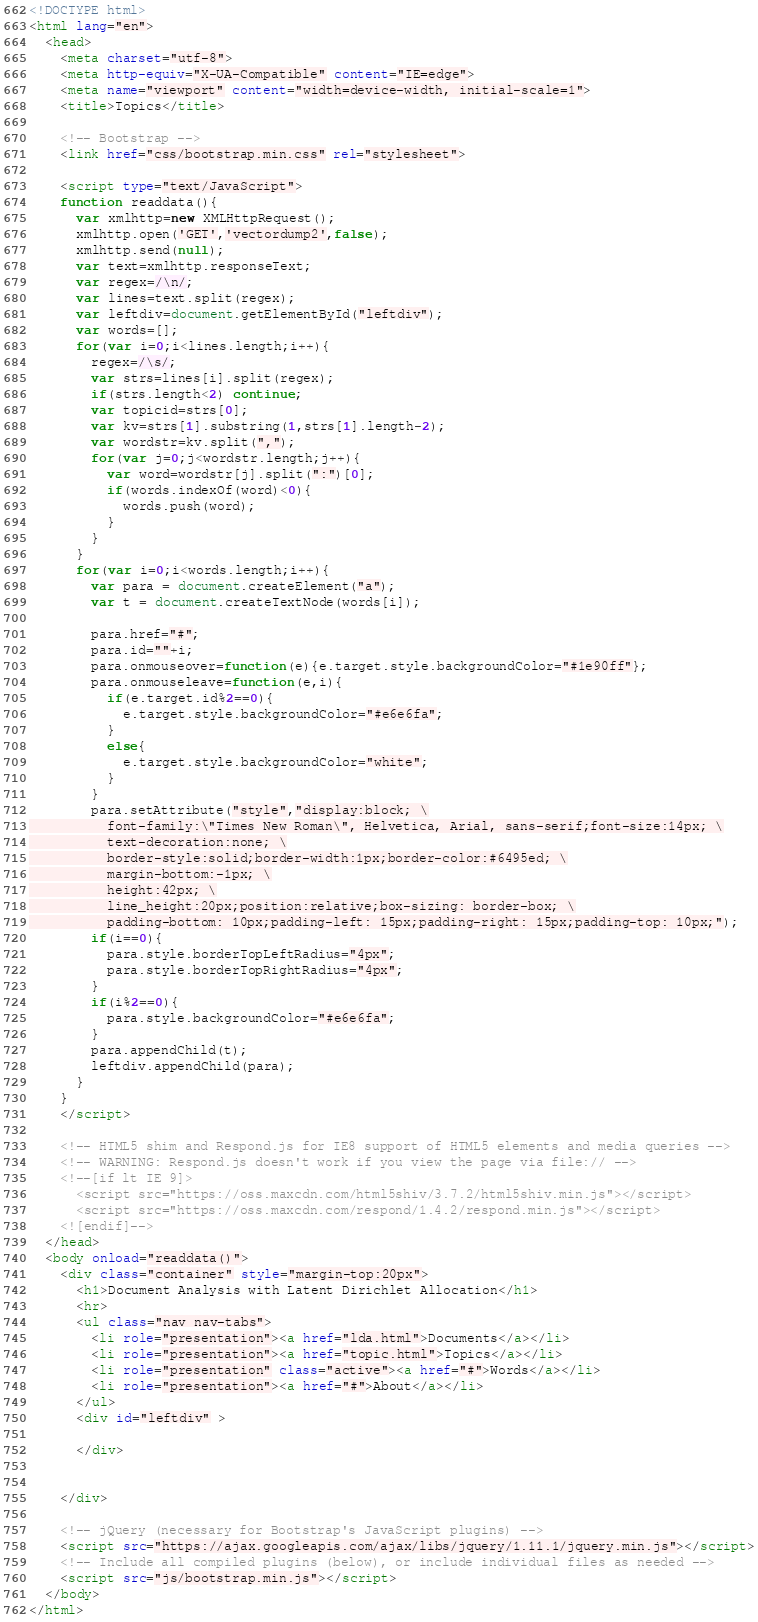Convert code to text. <code><loc_0><loc_0><loc_500><loc_500><_HTML_><!DOCTYPE html>
<html lang="en">
  <head>
    <meta charset="utf-8">
    <meta http-equiv="X-UA-Compatible" content="IE=edge">
    <meta name="viewport" content="width=device-width, initial-scale=1">
    <title>Topics</title>

    <!-- Bootstrap -->
    <link href="css/bootstrap.min.css" rel="stylesheet">

    <script type="text/JavaScript">
    function readdata(){
      var xmlhttp=new XMLHttpRequest();
      xmlhttp.open('GET','vectordump2',false);
      xmlhttp.send(null);
      var text=xmlhttp.responseText;
      var regex=/\n/;
      var lines=text.split(regex);
      var leftdiv=document.getElementById("leftdiv");
      var words=[];
      for(var i=0;i<lines.length;i++){
        regex=/\s/;
        var strs=lines[i].split(regex);
        if(strs.length<2) continue;
        var topicid=strs[0];
        var kv=strs[1].substring(1,strs[1].length-2);
        var wordstr=kv.split(",");
        for(var j=0;j<wordstr.length;j++){
          var word=wordstr[j].split(":")[0];
          if(words.indexOf(word)<0){
            words.push(word);
          }
        }
      }
      for(var i=0;i<words.length;i++){
        var para = document.createElement("a");
        var t = document.createTextNode(words[i]);

        para.href="#";
        para.id=""+i;
        para.onmouseover=function(e){e.target.style.backgroundColor="#1e90ff"};
        para.onmouseleave=function(e,i){
          if(e.target.id%2==0){
            e.target.style.backgroundColor="#e6e6fa";
          }
          else{
            e.target.style.backgroundColor="white";
          }
        }
        para.setAttribute("style","display:block; \
          font-family:\"Times New Roman\", Helvetica, Arial, sans-serif;font-size:14px; \
          text-decoration:none; \
          border-style:solid;border-width:1px;border-color:#6495ed; \
          margin-bottom:-1px; \
          height:42px; \
          line_height:20px;position:relative;box-sizing: border-box; \
          padding-bottom: 10px;padding-left: 15px;padding-right: 15px;padding-top: 10px;");
        if(i==0){
          para.style.borderTopLeftRadius="4px";
          para.style.borderTopRightRadius="4px";
        }
        if(i%2==0){
          para.style.backgroundColor="#e6e6fa";
        }
        para.appendChild(t);
        leftdiv.appendChild(para); 
      }
    }
    </script>

    <!-- HTML5 shim and Respond.js for IE8 support of HTML5 elements and media queries -->
    <!-- WARNING: Respond.js doesn't work if you view the page via file:// -->
    <!--[if lt IE 9]>
      <script src="https://oss.maxcdn.com/html5shiv/3.7.2/html5shiv.min.js"></script>
      <script src="https://oss.maxcdn.com/respond/1.4.2/respond.min.js"></script>
    <![endif]-->
  </head>
  <body onload="readdata()">
    <div class="container" style="margin-top:20px">
      <h1>Document Analysis with Latent Dirichlet Allocation</h1>
      <hr>
      <ul class="nav nav-tabs">
        <li role="presentation"><a href="lda.html">Documents</a></li>
        <li role="presentation"><a href="topic.html">Topics</a></li>
        <li role="presentation" class="active"><a href="#">Words</a></li>
        <li role="presentation"><a href="#">About</a></li>
      </ul>
      <div id="leftdiv" >
        
      </div>
      

    </div>

    <!-- jQuery (necessary for Bootstrap's JavaScript plugins) -->
    <script src="https://ajax.googleapis.com/ajax/libs/jquery/1.11.1/jquery.min.js"></script>
    <!-- Include all compiled plugins (below), or include individual files as needed -->
    <script src="js/bootstrap.min.js"></script>
  </body>
</html>
</code> 